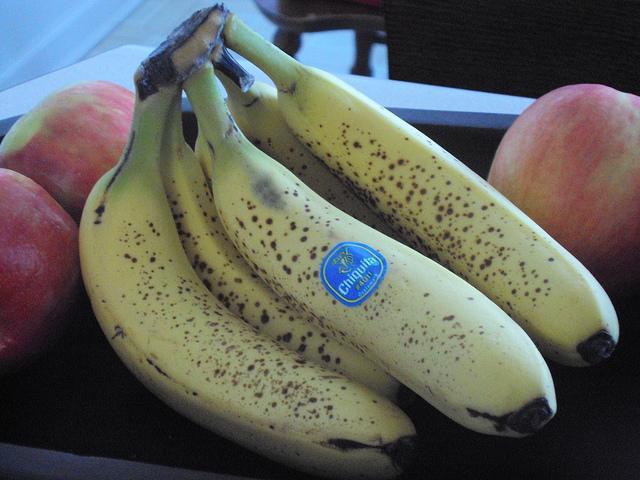Which fruit is too ripe?
Choose the correct response, then elucidate: 'Answer: answer
Rationale: rationale.'
Options: Apple, plum, peach, banana. Answer: banana.
Rationale: The item is losing its yellow color and is going brown. the item is also labeled with the brand name chiquita, which produces this kind of fruit. 